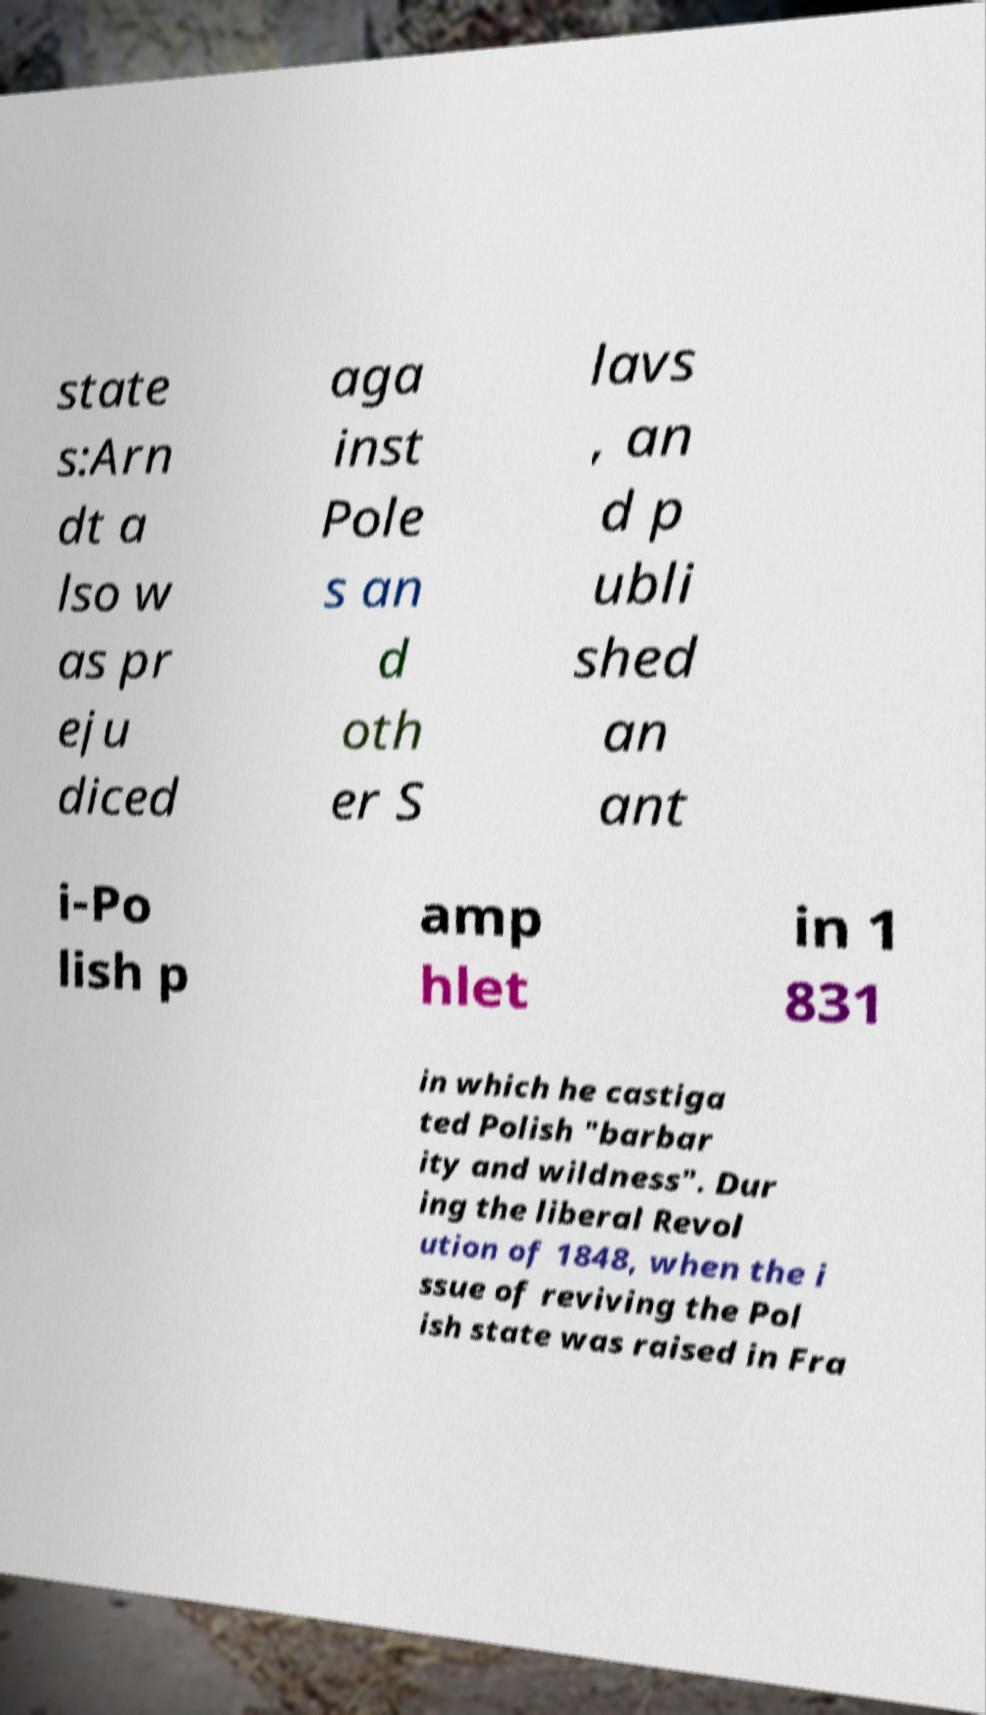What messages or text are displayed in this image? I need them in a readable, typed format. state s:Arn dt a lso w as pr eju diced aga inst Pole s an d oth er S lavs , an d p ubli shed an ant i-Po lish p amp hlet in 1 831 in which he castiga ted Polish "barbar ity and wildness". Dur ing the liberal Revol ution of 1848, when the i ssue of reviving the Pol ish state was raised in Fra 